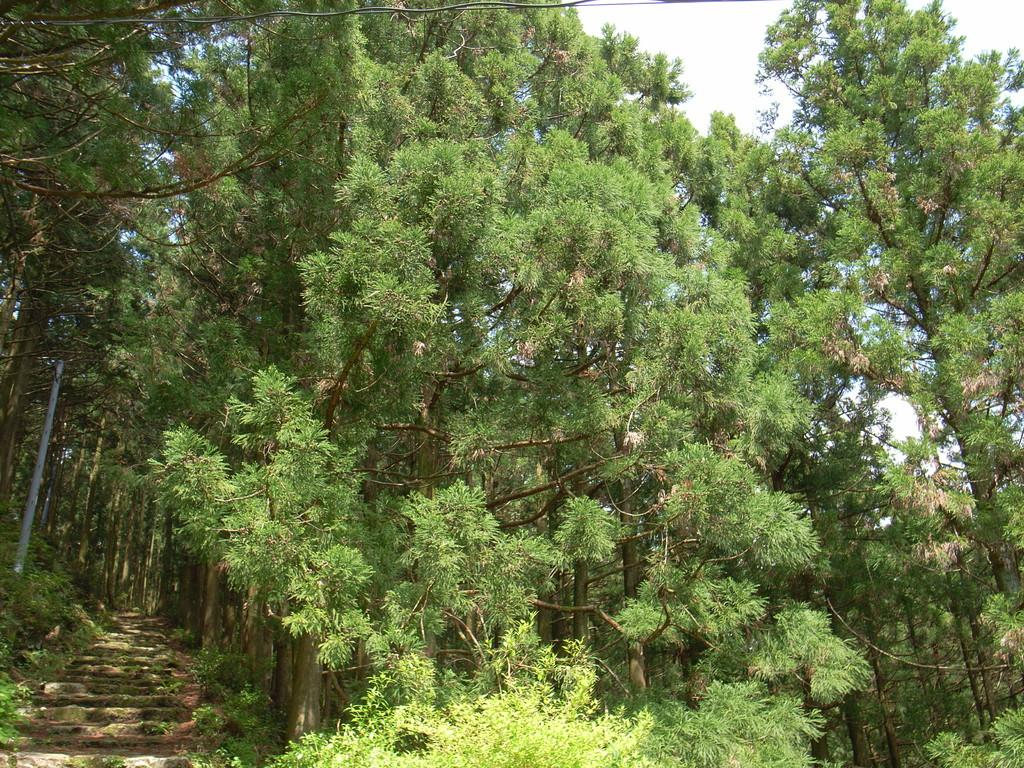What type of vegetation can be seen in the image? There are trees in the image. What architectural feature is present in the image? There are concrete stairs present in the image. What is the condition of the sky in the image? The sky is clear in the image. Can you see a nest in the trees in the image? There is no nest visible in the trees in the image. Is there a kitten playing on the concrete stairs in the image? There is no kitten present in the image. 